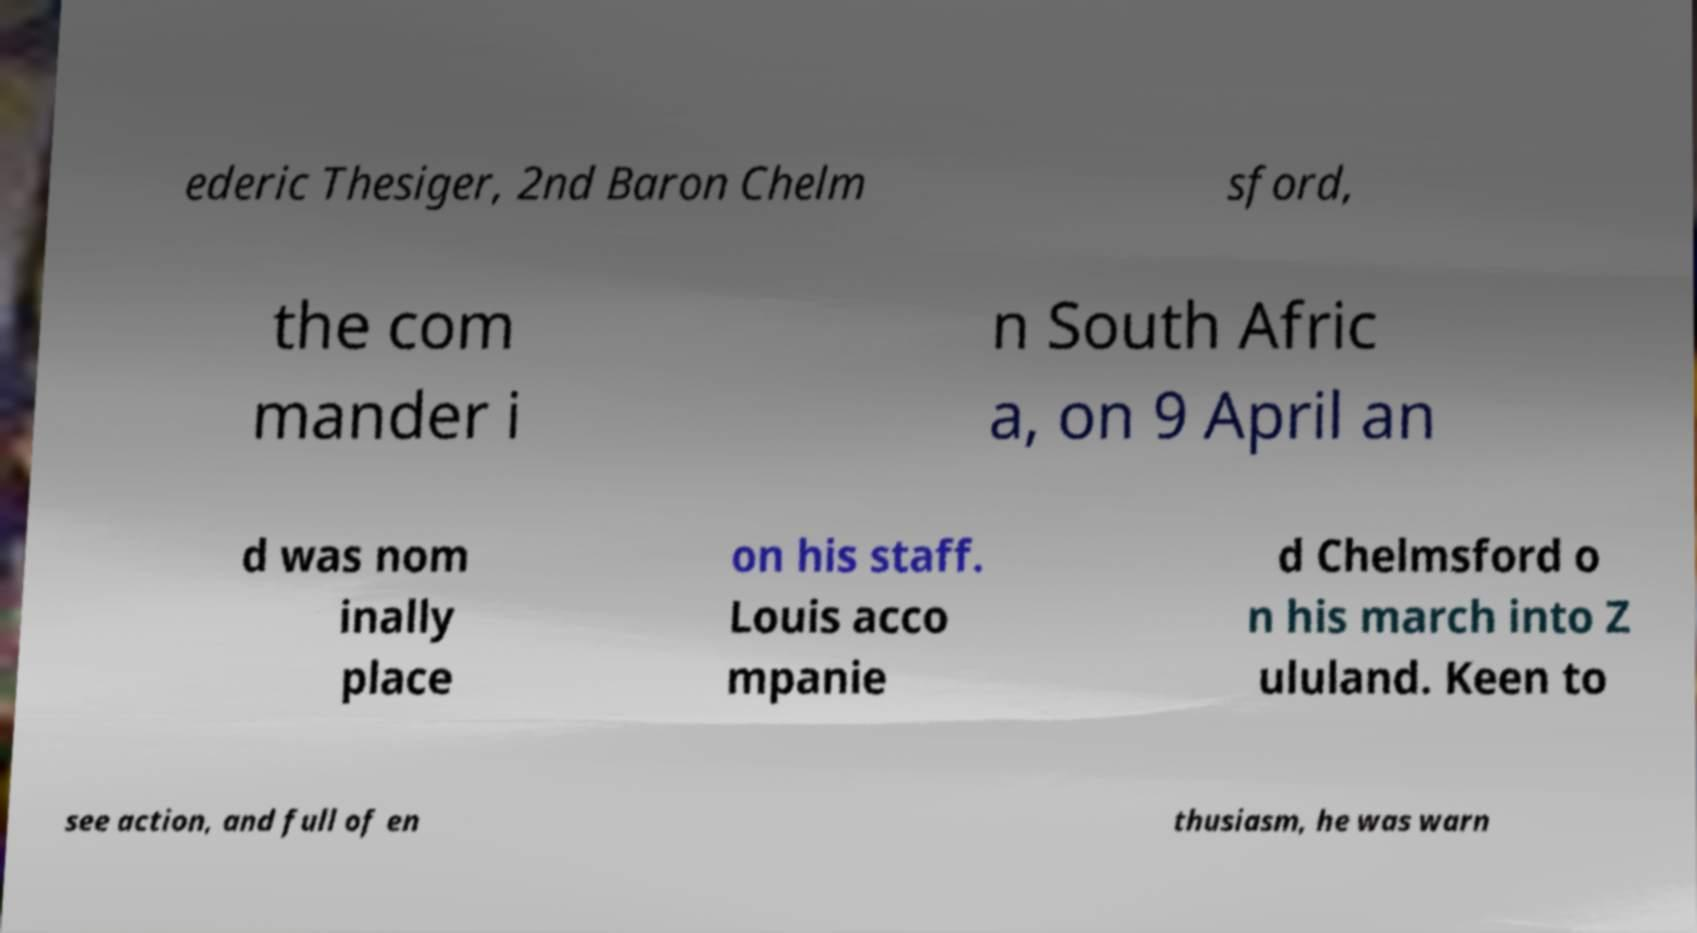For documentation purposes, I need the text within this image transcribed. Could you provide that? ederic Thesiger, 2nd Baron Chelm sford, the com mander i n South Afric a, on 9 April an d was nom inally place on his staff. Louis acco mpanie d Chelmsford o n his march into Z ululand. Keen to see action, and full of en thusiasm, he was warn 